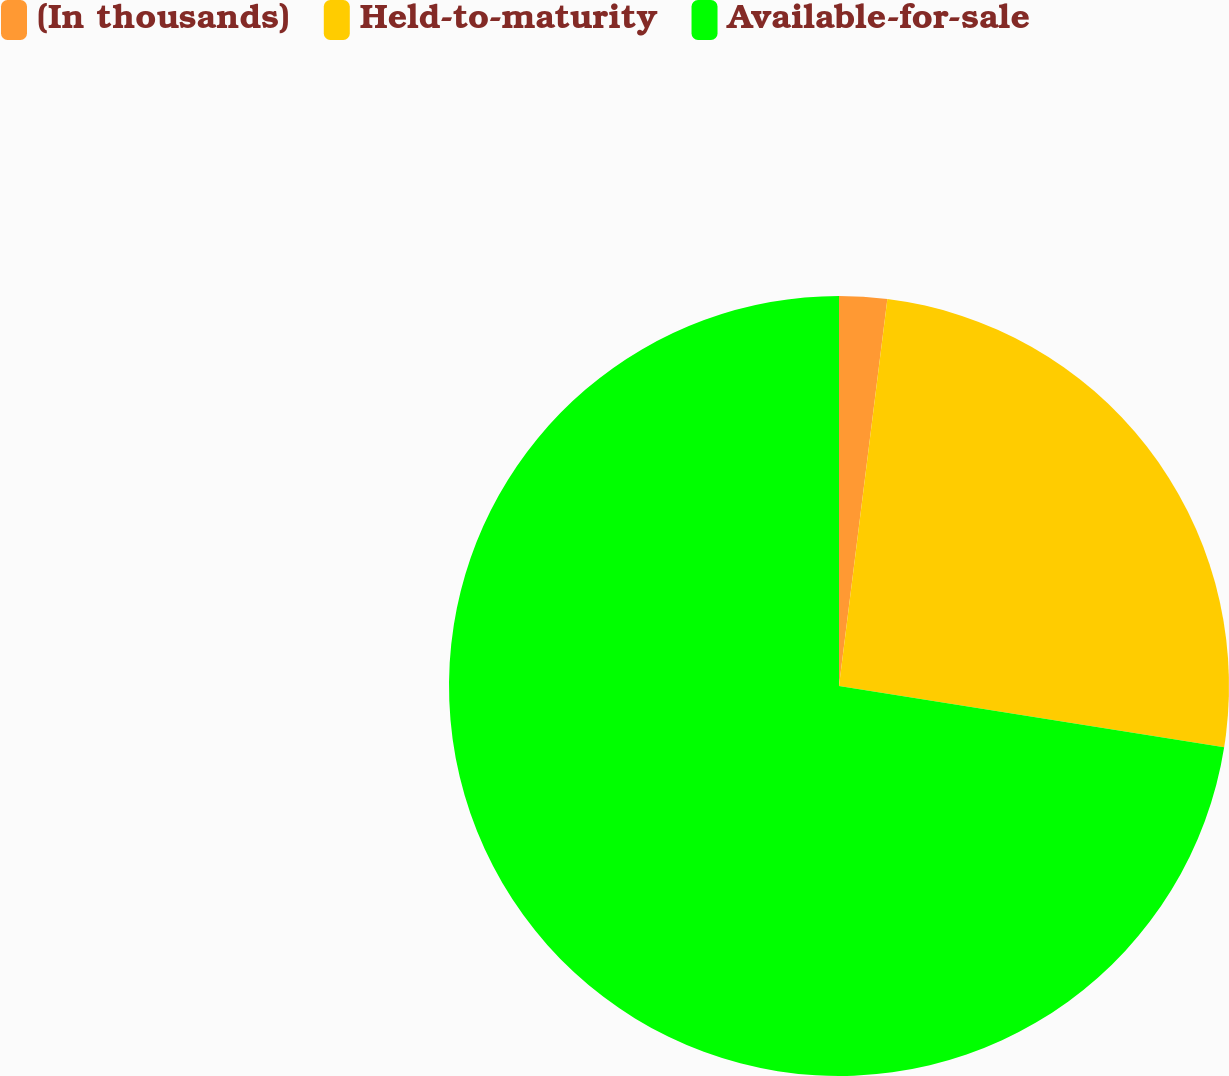<chart> <loc_0><loc_0><loc_500><loc_500><pie_chart><fcel>(In thousands)<fcel>Held-to-maturity<fcel>Available-for-sale<nl><fcel>1.98%<fcel>25.53%<fcel>72.49%<nl></chart> 